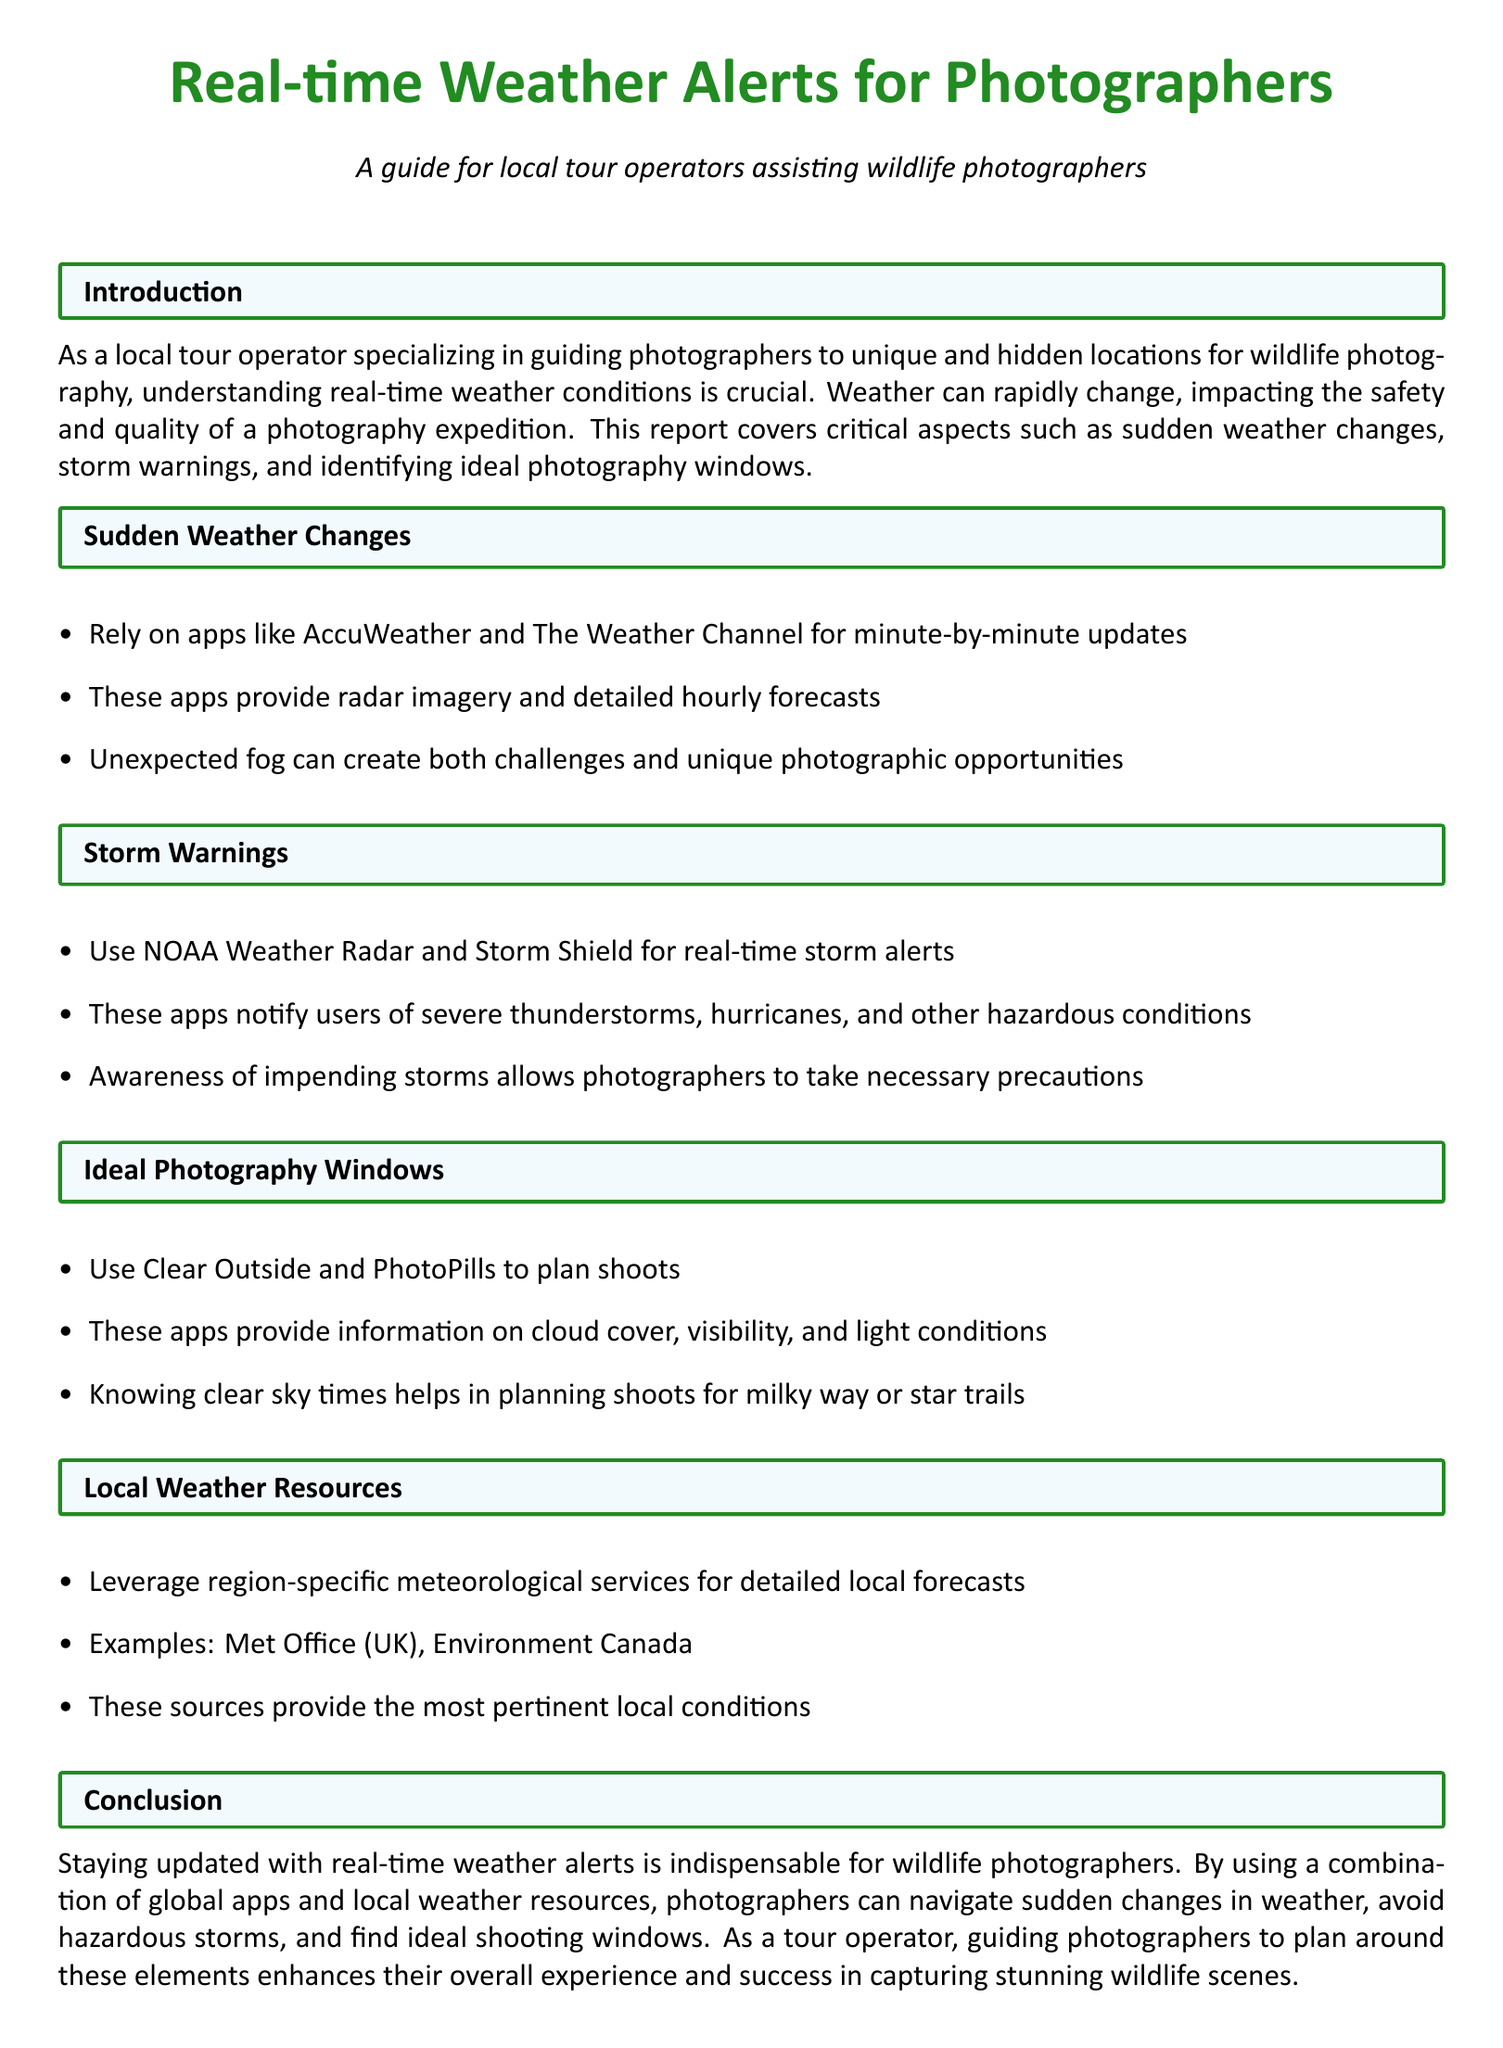What is the main purpose of the document? The document aims to guide local tour operators in assisting photographers with real-time weather alerts for wildlife photography.
Answer: Guiding local tour operators Which apps are recommended for tracking sudden weather changes? The document mentions AccuWeather and The Weather Channel for minute-by-minute updates.
Answer: AccuWeather, The Weather Channel What do photographers need to be aware of according to the storm warnings section? Photographers should be aware of severe thunderstorms, hurricanes, and other hazardous conditions.
Answer: Severe thunderstorms, hurricanes What tools can be used to identify ideal photography windows? Clear Outside and PhotoPills are recommended for planning shoots based on weather conditions.
Answer: Clear Outside, PhotoPills How does unexpected fog affect photography? Unexpected fog can create challenges but also unique photographic opportunities.
Answer: Challenges and opportunities What type of local services does the document suggest leveraging? The document suggests leveraging region-specific meteorological services for detailed local forecasts.
Answer: Region-specific meteorological services What is an example of a local weather resource mentioned in the document? The Met Office (UK) and Environment Canada are cited as examples of local weather resources.
Answer: Met Office, Environment Canada Why is it crucial for photographers to stay updated with real-time weather alerts? Staying updated helps them navigate sudden changes, avoid storms, and find ideal shooting windows.
Answer: To navigate sudden changes and avoid storms 